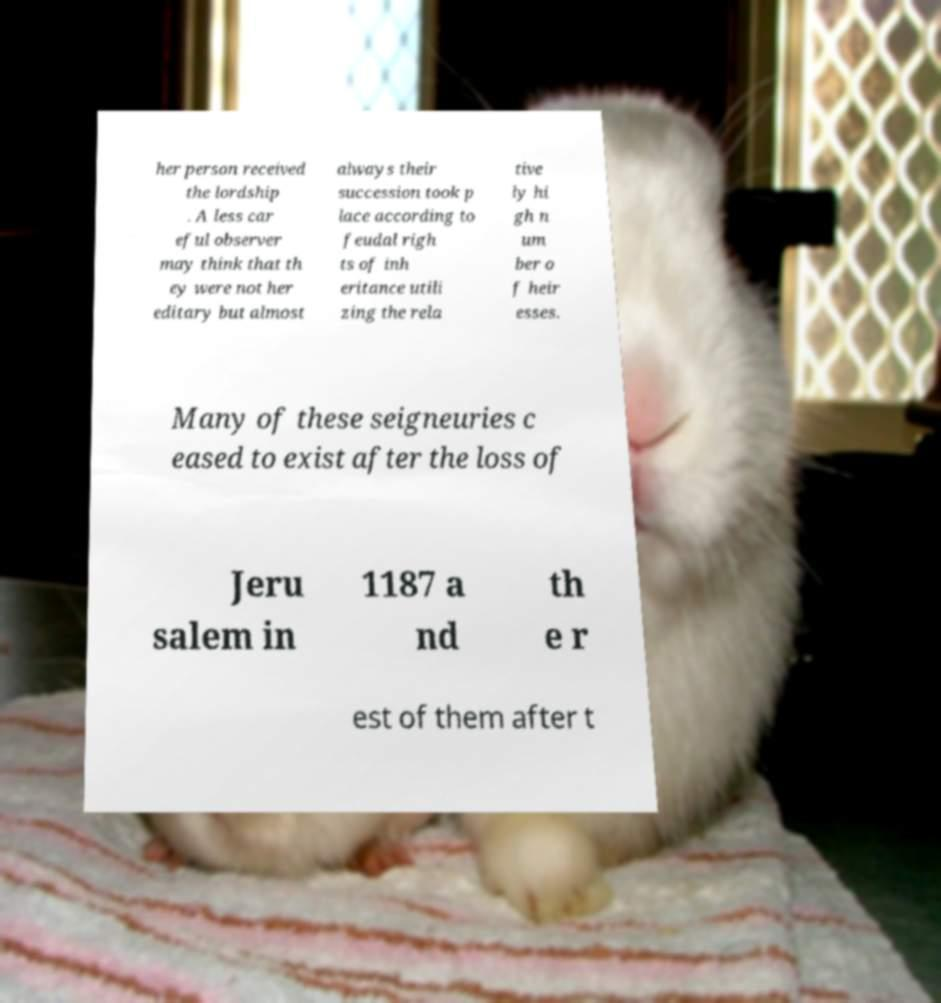Could you extract and type out the text from this image? her person received the lordship . A less car eful observer may think that th ey were not her editary but almost always their succession took p lace according to feudal righ ts of inh eritance utili zing the rela tive ly hi gh n um ber o f heir esses. Many of these seigneuries c eased to exist after the loss of Jeru salem in 1187 a nd th e r est of them after t 